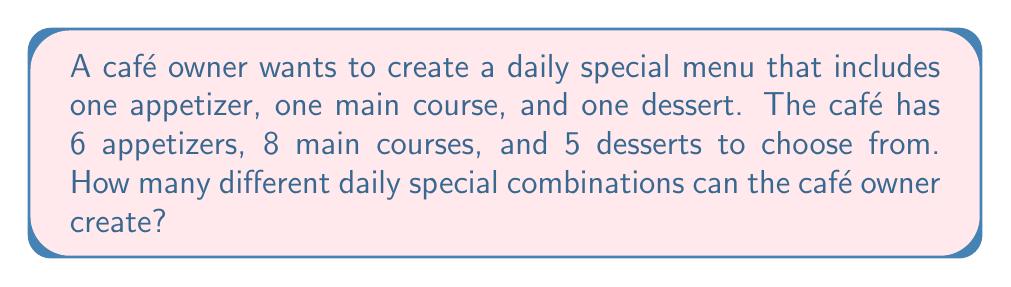Could you help me with this problem? Let's approach this step-by-step:

1) We need to select one item from each category:
   - 1 appetizer from 6 options
   - 1 main course from 8 options
   - 1 dessert from 5 options

2) This is a combination problem where the order doesn't matter within each category, but we're selecting one from each category.

3) For each category, we're using the combination formula $C(n,r) = \frac{n!}{r!(n-r)!}$, where $n$ is the number of options and $r$ is the number we're choosing.

4) However, since we're choosing only one item from each category, it simplifies to just the number of options in each category.

5) To find the total number of possible combinations, we multiply the number of choices for each category:

   $$ \text{Total combinations} = 6 \times 8 \times 5 $$

6) Calculating:
   $$ 6 \times 8 \times 5 = 48 \times 5 = 240 $$

Therefore, the café owner can create 240 different daily special combinations.
Answer: 240 